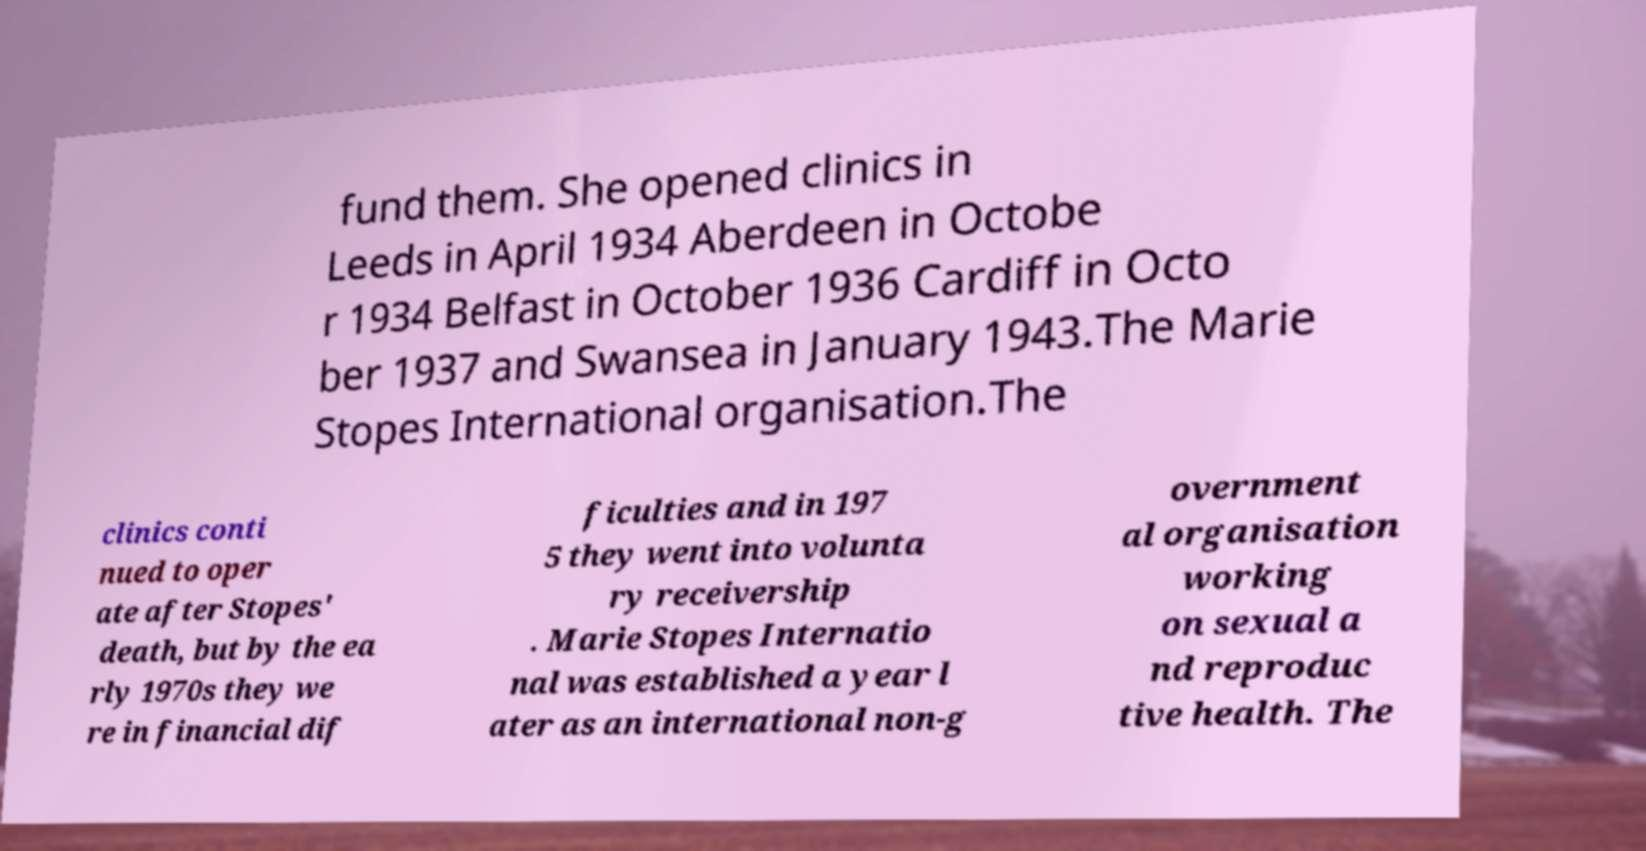Please identify and transcribe the text found in this image. fund them. She opened clinics in Leeds in April 1934 Aberdeen in Octobe r 1934 Belfast in October 1936 Cardiff in Octo ber 1937 and Swansea in January 1943.The Marie Stopes International organisation.The clinics conti nued to oper ate after Stopes' death, but by the ea rly 1970s they we re in financial dif ficulties and in 197 5 they went into volunta ry receivership . Marie Stopes Internatio nal was established a year l ater as an international non-g overnment al organisation working on sexual a nd reproduc tive health. The 